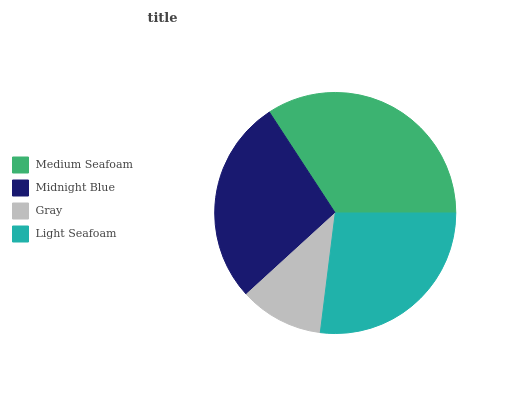Is Gray the minimum?
Answer yes or no. Yes. Is Medium Seafoam the maximum?
Answer yes or no. Yes. Is Midnight Blue the minimum?
Answer yes or no. No. Is Midnight Blue the maximum?
Answer yes or no. No. Is Medium Seafoam greater than Midnight Blue?
Answer yes or no. Yes. Is Midnight Blue less than Medium Seafoam?
Answer yes or no. Yes. Is Midnight Blue greater than Medium Seafoam?
Answer yes or no. No. Is Medium Seafoam less than Midnight Blue?
Answer yes or no. No. Is Midnight Blue the high median?
Answer yes or no. Yes. Is Light Seafoam the low median?
Answer yes or no. Yes. Is Light Seafoam the high median?
Answer yes or no. No. Is Midnight Blue the low median?
Answer yes or no. No. 